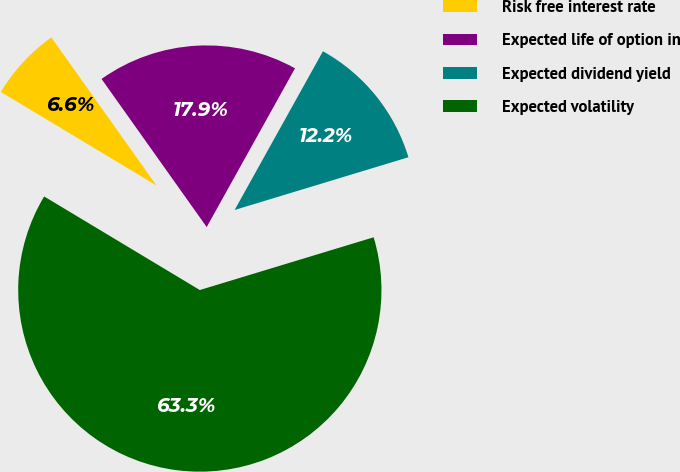Convert chart. <chart><loc_0><loc_0><loc_500><loc_500><pie_chart><fcel>Risk free interest rate<fcel>Expected life of option in<fcel>Expected dividend yield<fcel>Expected volatility<nl><fcel>6.56%<fcel>17.91%<fcel>12.23%<fcel>63.31%<nl></chart> 